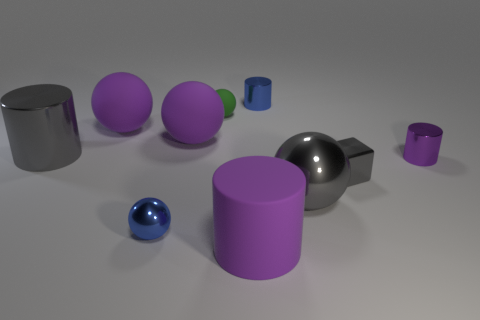Subtract all green balls. How many balls are left? 4 Subtract all gray spheres. How many spheres are left? 4 Subtract all cyan spheres. Subtract all red blocks. How many spheres are left? 5 Subtract all blocks. How many objects are left? 9 Add 8 tiny green objects. How many tiny green objects exist? 9 Subtract 0 brown cubes. How many objects are left? 10 Subtract all small yellow matte cubes. Subtract all blue metal things. How many objects are left? 8 Add 5 large purple things. How many large purple things are left? 8 